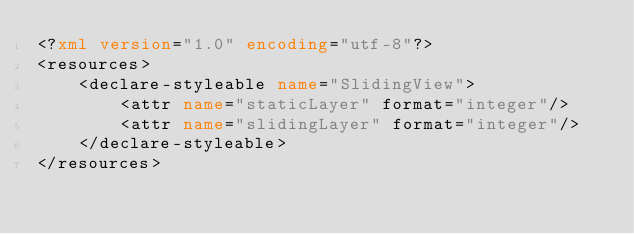Convert code to text. <code><loc_0><loc_0><loc_500><loc_500><_XML_><?xml version="1.0" encoding="utf-8"?>
<resources>
    <declare-styleable name="SlidingView">
        <attr name="staticLayer" format="integer"/>
        <attr name="slidingLayer" format="integer"/>
    </declare-styleable>
</resources></code> 